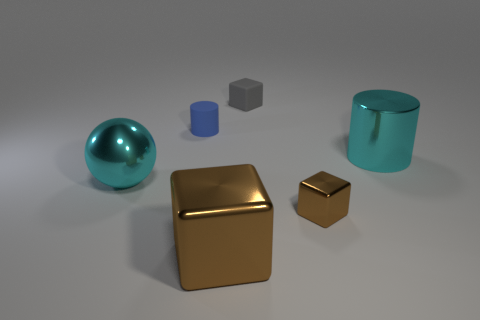There is a gray object that is the same shape as the large brown object; what material is it?
Make the answer very short. Rubber. What material is the tiny thing that is to the right of the tiny cylinder and left of the tiny shiny cube?
Your answer should be very brief. Rubber. Are there fewer shiny things behind the large cylinder than gray matte cubes in front of the large cyan shiny sphere?
Your answer should be very brief. No. What number of other things are there of the same size as the gray rubber cube?
Provide a succinct answer. 2. There is a large cyan thing on the left side of the big cyan shiny thing that is on the right side of the block that is behind the tiny blue matte cylinder; what is its shape?
Give a very brief answer. Sphere. What number of brown things are either matte objects or rubber cubes?
Ensure brevity in your answer.  0. What number of matte objects are to the right of the cylinder that is to the left of the large metallic cylinder?
Make the answer very short. 1. Are there any other things of the same color as the small shiny cube?
Offer a very short reply. Yes. What shape is the tiny gray object that is made of the same material as the small cylinder?
Offer a terse response. Cube. Is the color of the large shiny sphere the same as the big shiny cylinder?
Ensure brevity in your answer.  Yes. 